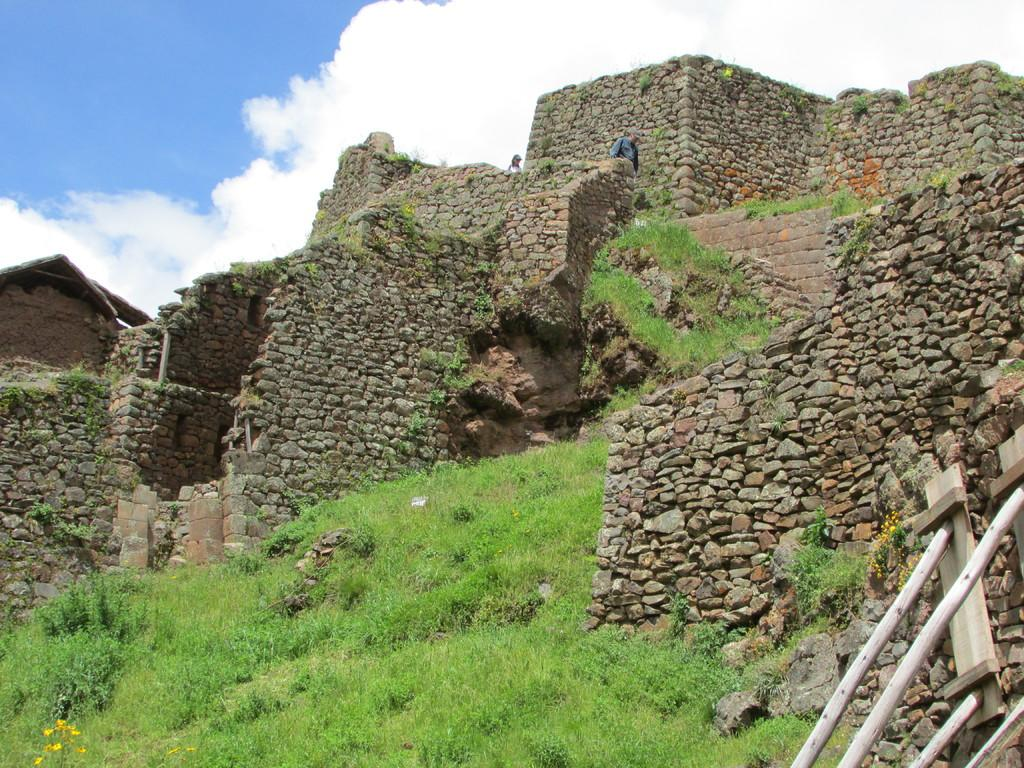What type of vegetation is present in the image? There is grass in the image. What type of structures can be seen in the image? There are wooden poles and a stone wall in the image. What is the condition of the sky in the image? The sky is cloudy in the image. How many people are visible in the image? There are two people wearing clothes in the image. What type of rake is being used to care for the grass in the image? There is no rake present in the image, and no one is shown caring for the grass. 